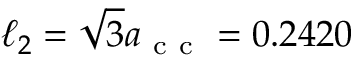<formula> <loc_0><loc_0><loc_500><loc_500>\ell _ { 2 } = \sqrt { 3 } a _ { c c } = 0 . 2 4 2 0</formula> 